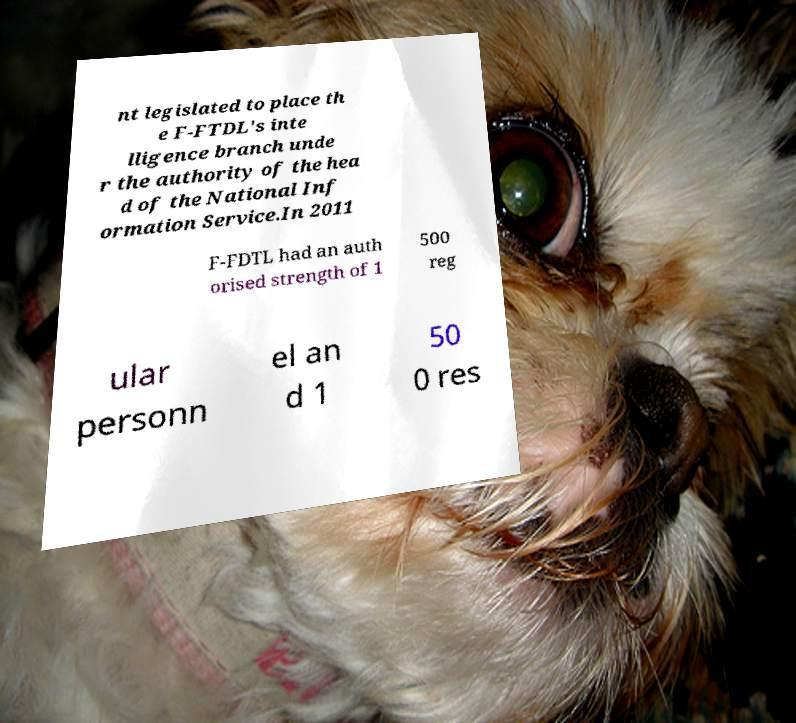I need the written content from this picture converted into text. Can you do that? nt legislated to place th e F-FTDL's inte lligence branch unde r the authority of the hea d of the National Inf ormation Service.In 2011 F-FDTL had an auth orised strength of 1 500 reg ular personn el an d 1 50 0 res 